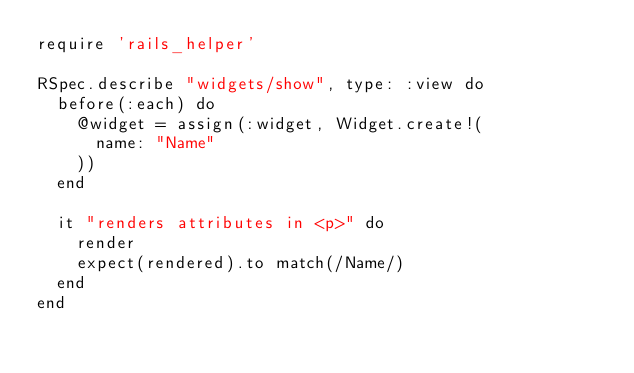Convert code to text. <code><loc_0><loc_0><loc_500><loc_500><_Ruby_>require 'rails_helper'

RSpec.describe "widgets/show", type: :view do
  before(:each) do
    @widget = assign(:widget, Widget.create!(
      name: "Name"
    ))
  end

  it "renders attributes in <p>" do
    render
    expect(rendered).to match(/Name/)
  end
end
</code> 